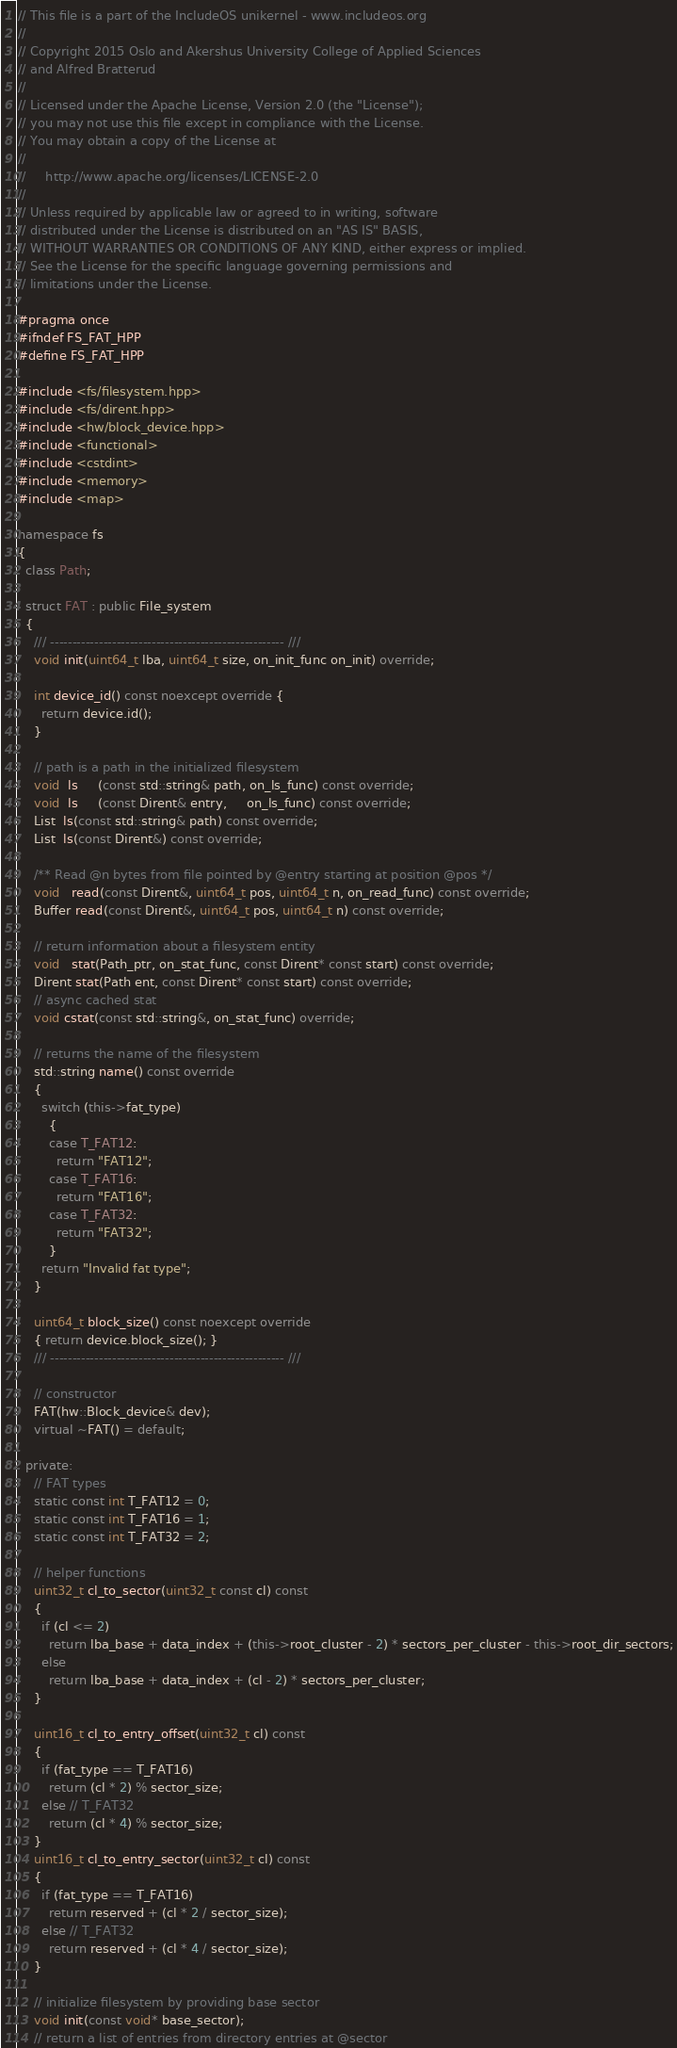Convert code to text. <code><loc_0><loc_0><loc_500><loc_500><_C++_>// This file is a part of the IncludeOS unikernel - www.includeos.org
//
// Copyright 2015 Oslo and Akershus University College of Applied Sciences
// and Alfred Bratterud
//
// Licensed under the Apache License, Version 2.0 (the "License");
// you may not use this file except in compliance with the License.
// You may obtain a copy of the License at
//
//     http://www.apache.org/licenses/LICENSE-2.0
//
// Unless required by applicable law or agreed to in writing, software
// distributed under the License is distributed on an "AS IS" BASIS,
// WITHOUT WARRANTIES OR CONDITIONS OF ANY KIND, either express or implied.
// See the License for the specific language governing permissions and
// limitations under the License.

#pragma once
#ifndef FS_FAT_HPP
#define FS_FAT_HPP

#include <fs/filesystem.hpp>
#include <fs/dirent.hpp>
#include <hw/block_device.hpp>
#include <functional>
#include <cstdint>
#include <memory>
#include <map>

namespace fs
{
  class Path;

  struct FAT : public File_system
  {
    /// ----------------------------------------------------- ///
    void init(uint64_t lba, uint64_t size, on_init_func on_init) override;

    int device_id() const noexcept override {
      return device.id();
    }

    // path is a path in the initialized filesystem
    void  ls     (const std::string& path, on_ls_func) const override;
    void  ls     (const Dirent& entry,     on_ls_func) const override;
    List  ls(const std::string& path) const override;
    List  ls(const Dirent&) const override;

    /** Read @n bytes from file pointed by @entry starting at position @pos */
    void   read(const Dirent&, uint64_t pos, uint64_t n, on_read_func) const override;
    Buffer read(const Dirent&, uint64_t pos, uint64_t n) const override;

    // return information about a filesystem entity
    void   stat(Path_ptr, on_stat_func, const Dirent* const start) const override;
    Dirent stat(Path ent, const Dirent* const start) const override;
    // async cached stat
    void cstat(const std::string&, on_stat_func) override;

    // returns the name of the filesystem
    std::string name() const override
    {
      switch (this->fat_type)
        {
        case T_FAT12:
          return "FAT12";
        case T_FAT16:
          return "FAT16";
        case T_FAT32:
          return "FAT32";
        }
      return "Invalid fat type";
    }

    uint64_t block_size() const noexcept override
    { return device.block_size(); }
    /// ----------------------------------------------------- ///

    // constructor
    FAT(hw::Block_device& dev);
    virtual ~FAT() = default;

  private:
    // FAT types
    static const int T_FAT12 = 0;
    static const int T_FAT16 = 1;
    static const int T_FAT32 = 2;

    // helper functions
    uint32_t cl_to_sector(uint32_t const cl) const
    {
      if (cl <= 2)
        return lba_base + data_index + (this->root_cluster - 2) * sectors_per_cluster - this->root_dir_sectors;
      else
        return lba_base + data_index + (cl - 2) * sectors_per_cluster;
    }

    uint16_t cl_to_entry_offset(uint32_t cl) const
    {
      if (fat_type == T_FAT16)
        return (cl * 2) % sector_size;
      else // T_FAT32
        return (cl * 4) % sector_size;
    }
    uint16_t cl_to_entry_sector(uint32_t cl) const
    {
      if (fat_type == T_FAT16)
        return reserved + (cl * 2 / sector_size);
      else // T_FAT32
        return reserved + (cl * 4 / sector_size);
    }

    // initialize filesystem by providing base sector
    void init(const void* base_sector);
    // return a list of entries from directory entries at @sector</code> 